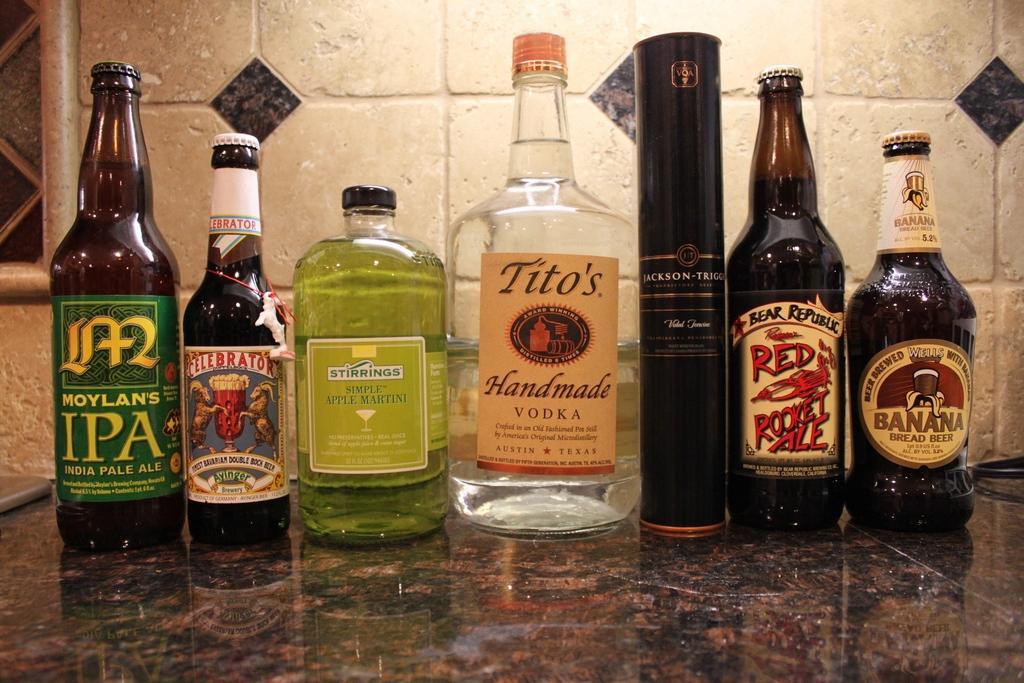Could you give a brief overview of what you see in this image? In this image I can see number of bottles. 